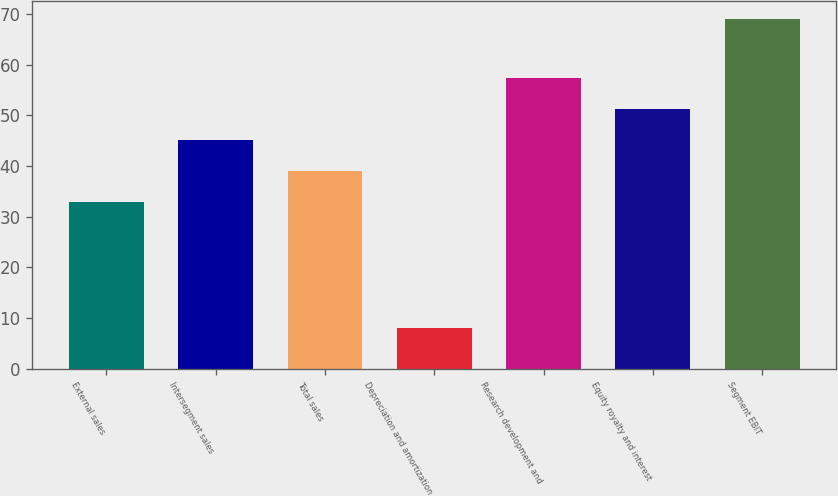<chart> <loc_0><loc_0><loc_500><loc_500><bar_chart><fcel>External sales<fcel>Intersegment sales<fcel>Total sales<fcel>Depreciation and amortization<fcel>Research development and<fcel>Equity royalty and interest<fcel>Segment EBIT<nl><fcel>33<fcel>45.2<fcel>39.1<fcel>8<fcel>57.4<fcel>51.3<fcel>69<nl></chart> 